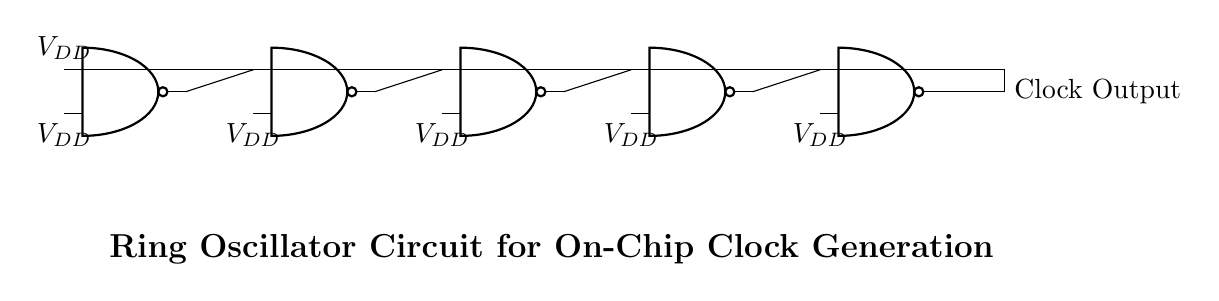What type of gates are used in this circuit? The circuit consists of NAND gates, as indicated by the symbols shown in the diagram.
Answer: NAND gates How many NAND gates are present in the circuit? There are five NAND gates in total, as each NAND gate is represented in the diagram, and they are numbered sequentially from one to five.
Answer: Five What is the output of the ring oscillator? The output is the clock signal generated from the last NAND gate, which is directly connected to the output node indicated in the diagram.
Answer: Clock Output What is the power supply voltage for the NAND gates? The voltage supply is indicated as VDD, which suggests a common positive voltage input for the NAND gates, typically used in digital circuits.
Answer: VDD Why does this circuit form a ring oscillator? The circuit creates a feedback loop through the interconnection of the NAND gates, allowing for oscillation due to the propagation delay, which is characteristic of ring oscillators.
Answer: Feedback loop What role do the NAND gate inputs play in oscillation? The inputs are crucial for determining the switching states of the NAND gates, enabling them to change their output based on the input states, thus allowing oscillation to occur.
Answer: Switching states 